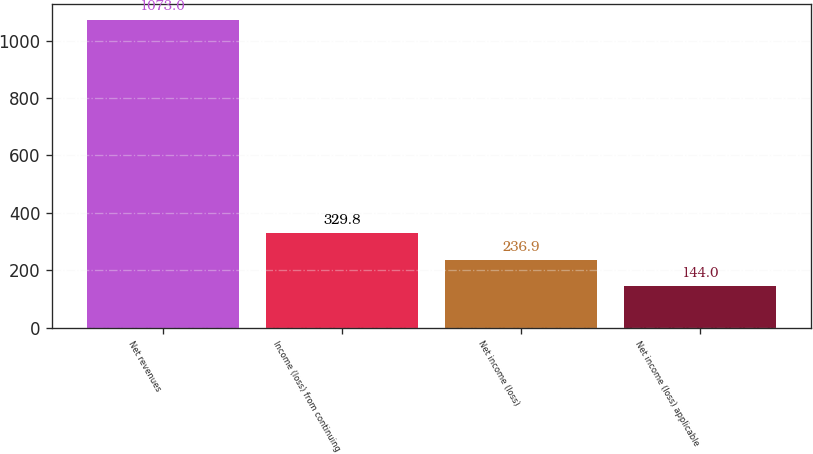<chart> <loc_0><loc_0><loc_500><loc_500><bar_chart><fcel>Net revenues<fcel>Income (loss) from continuing<fcel>Net income (loss)<fcel>Net income (loss) applicable<nl><fcel>1073<fcel>329.8<fcel>236.9<fcel>144<nl></chart> 